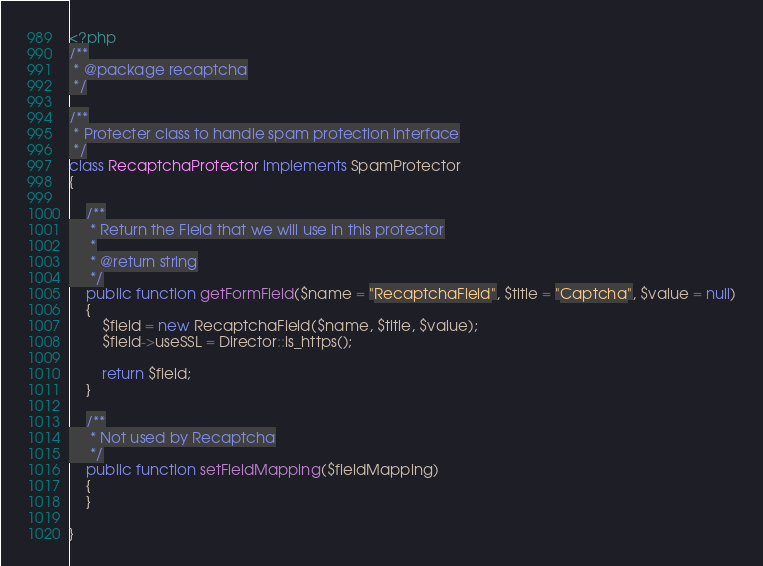Convert code to text. <code><loc_0><loc_0><loc_500><loc_500><_PHP_><?php
/**
 * @package recaptcha
 */

/**
 * Protecter class to handle spam protection interface
 */
class RecaptchaProtector implements SpamProtector
{

    /**
     * Return the Field that we will use in this protector
     *
     * @return string
     */
    public function getFormField($name = "RecaptchaField", $title = "Captcha", $value = null)
    {
        $field = new RecaptchaField($name, $title, $value);
        $field->useSSL = Director::is_https();

        return $field;
    }

    /**
     * Not used by Recaptcha
     */
    public function setFieldMapping($fieldMapping)
    {
    }

}
</code> 